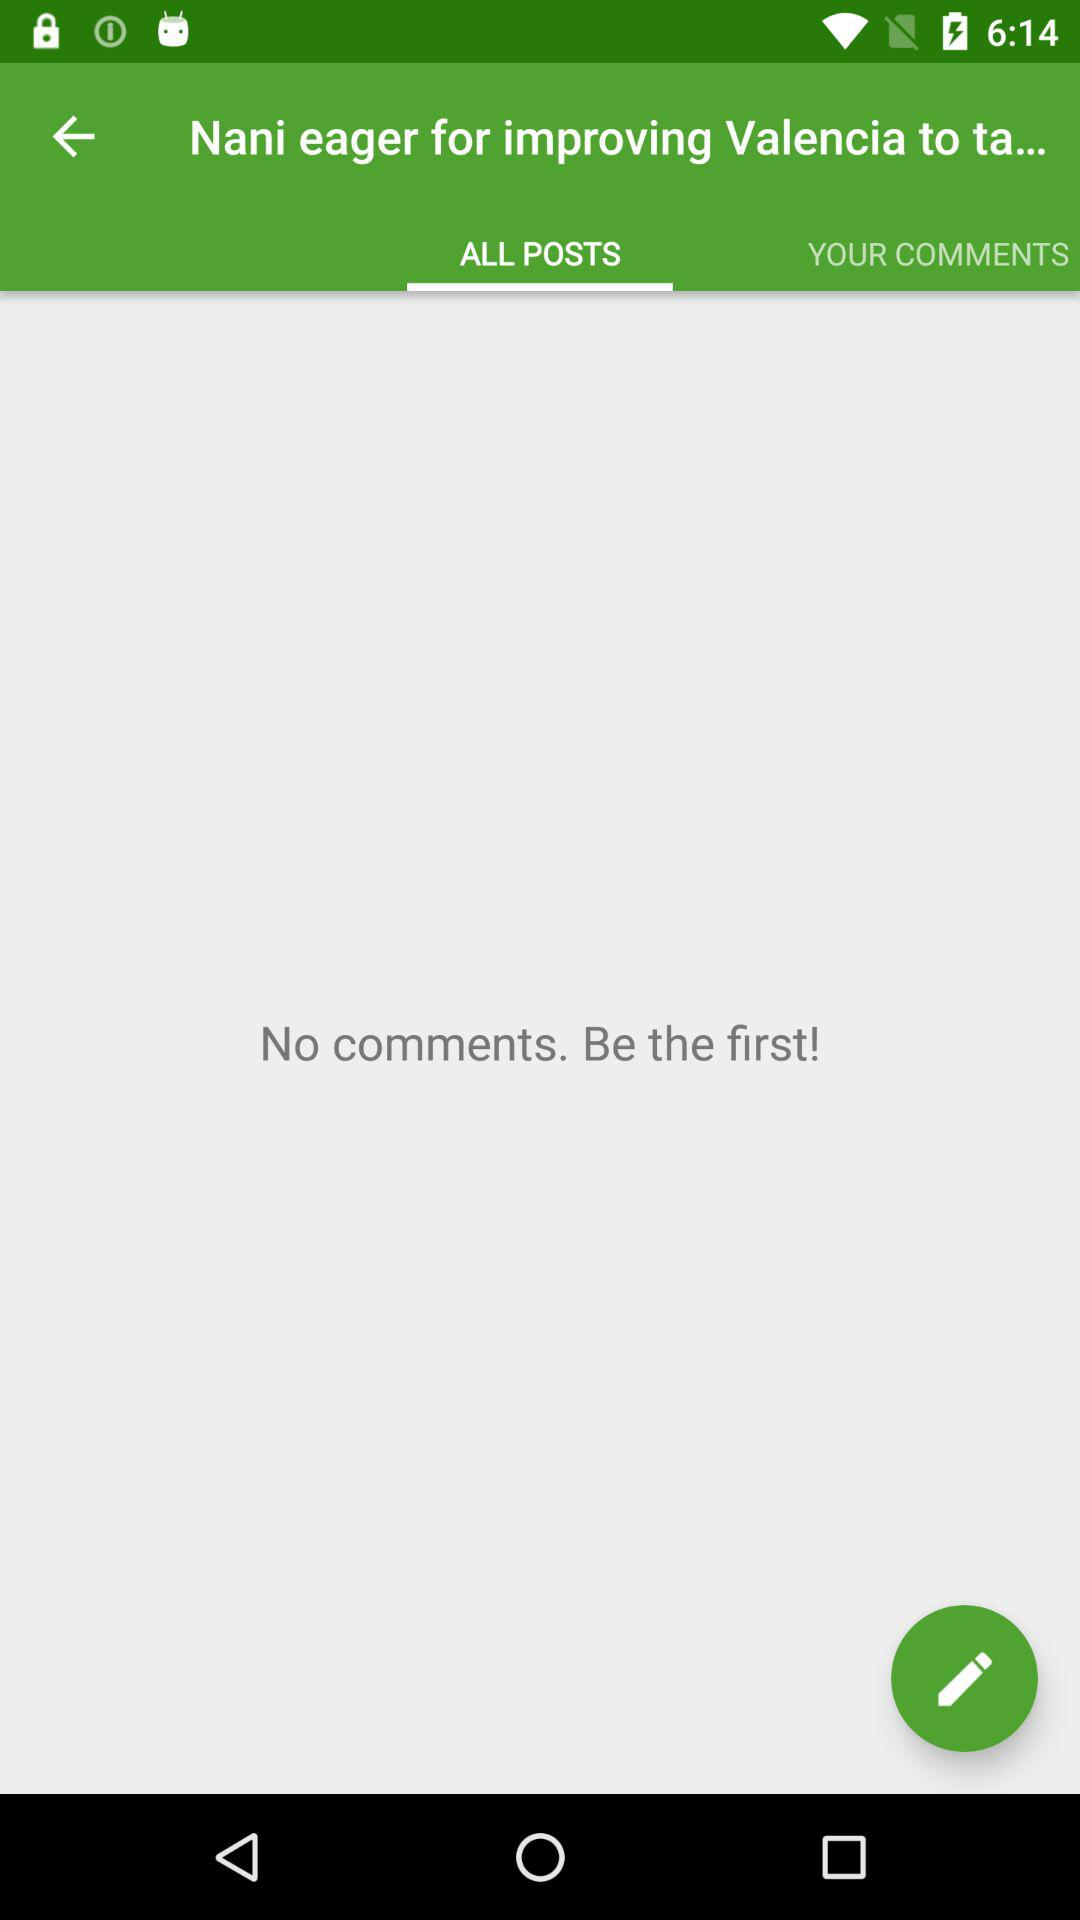How many items are in "YOUR COMMENTS"?
When the provided information is insufficient, respond with <no answer>. <no answer> 